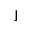<formula> <loc_0><loc_0><loc_500><loc_500>\rfloor</formula> 